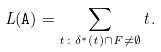<formula> <loc_0><loc_0><loc_500><loc_500>L ( \mathtt A ) = \sum _ { t \colon \delta ^ { * } ( t ) \cap F \neq \emptyset } t .</formula> 